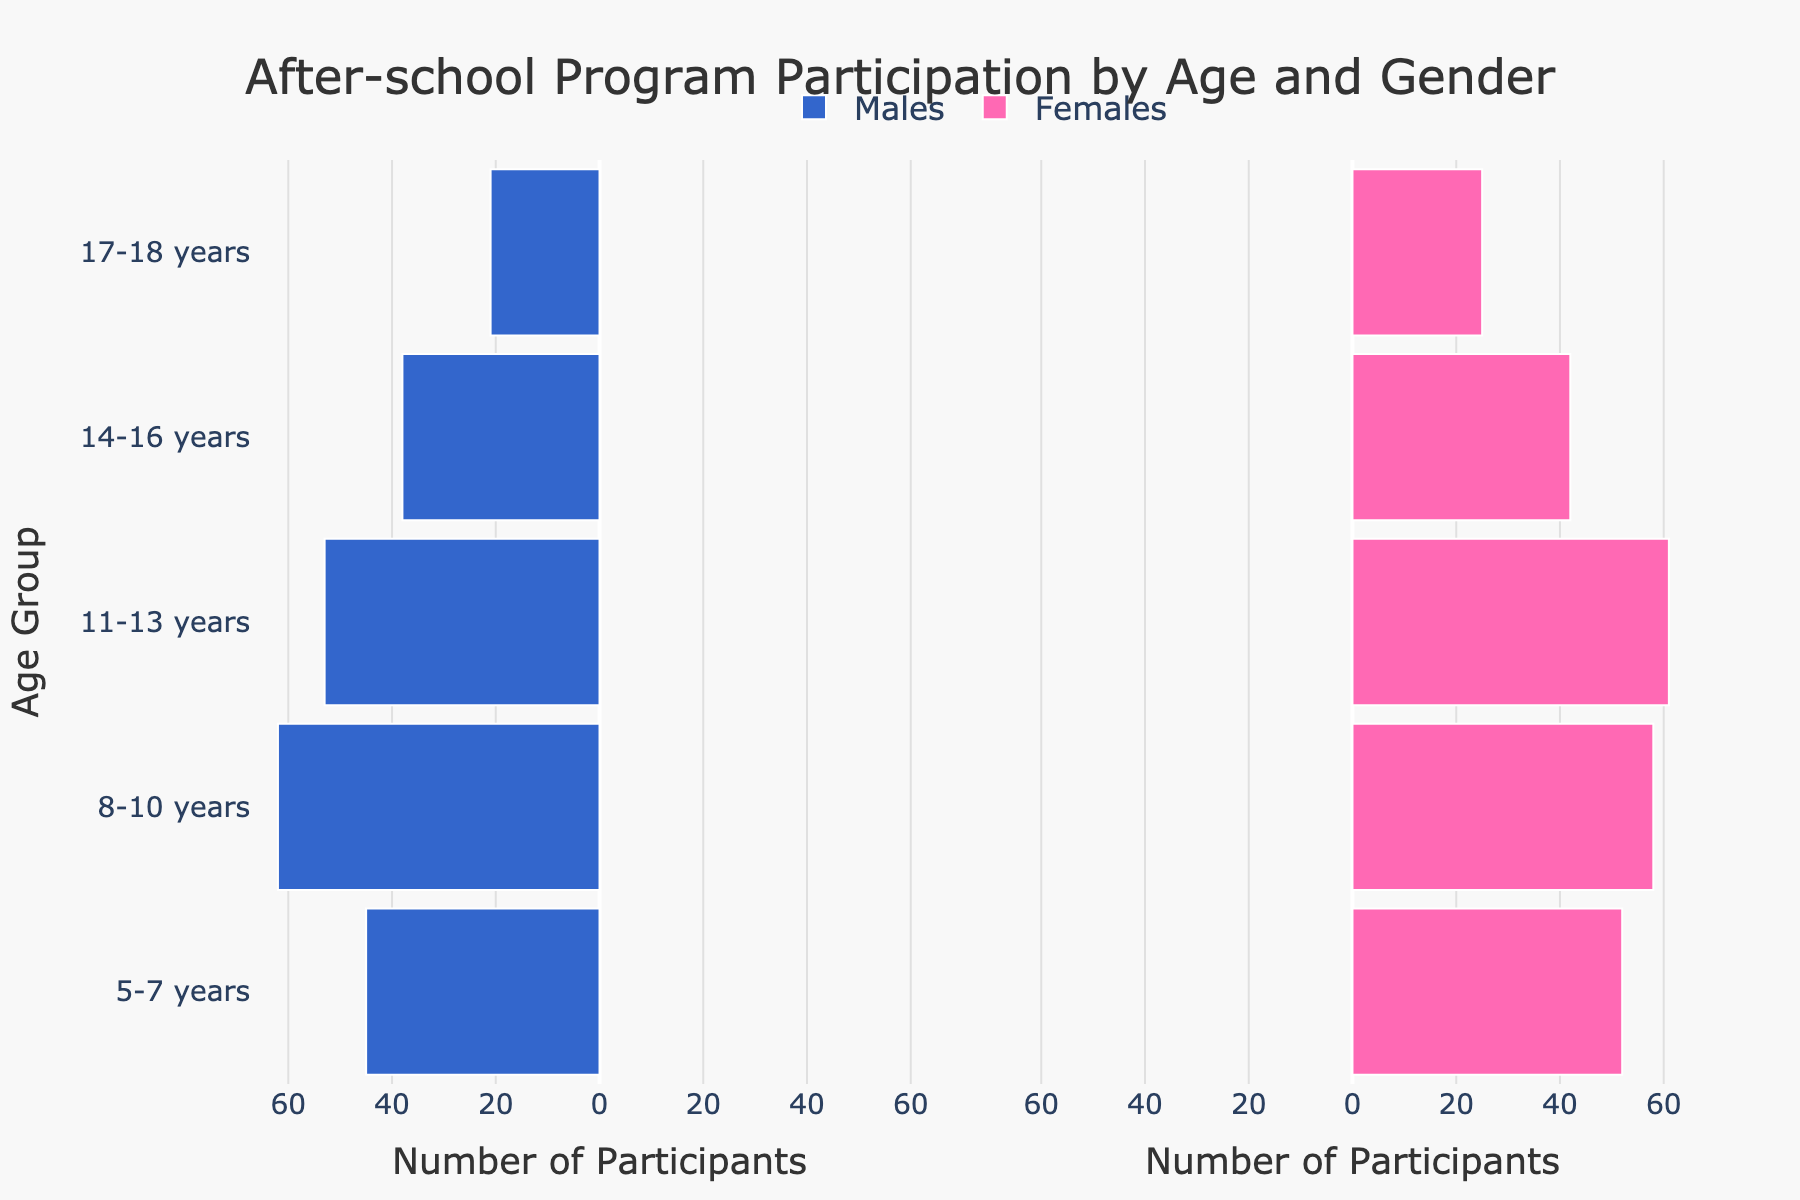What is the title of the figure? The title of the figure is located at the top and provides a succinct description of what the figure represents. The title here is "After-school Program Participation by Age and Gender."
Answer: After-school Program Participation by Age and Gender What colors are used to represent males and females in the figure? The figure uses two distinct colors to represent different genders. Males are represented by blue bars, and females are represented by pink bars.
Answer: Blue for males and pink for females Which age group has the highest number of female participants? To find this, look for the tallest pink bar (which represents females) across all the age groups. The age group "11-13 years" has the tallest pink bar, indicating the highest female participation.
Answer: 11-13 years How many male participants are there in the 8-10 years age group? Check the length of the blue bar corresponding to the "8-10 years" age group. The value there is '-62', which represents 62 male participants when considering the negative sign is just for display.
Answer: 62 What is the difference between the number of male and female participants in the 5-7 years age group? To find the difference, subtract the number of males from the number of females for the 5-7 years age group (52 - 45). This calculation shows there are 7 more females than males in this age group.
Answer: 7 Which gender has more participants in the 14-16 years age group? Compare the lengths of the blue and pink bars for the 14-16 years age group. The bar representing females is slightly taller, indicating more female participants.
Answer: Females What is the total number of participants aged 17-18 years old? Sum the number of male and female participants in the 17-18 years age group (21 males + 25 females). The total number of participants in this age group is 46.
Answer: 46 How does participation generally change as age increases from 5-7 years to 17-18 years? Examine the overall trend in the bar lengths from the youngest (5-7 years) to the oldest (17-18 years). As age increases, both the male and female participation rates generally decrease.
Answer: Decreases What's the gender ratio (males to females) in the 11-13 years age group? Calculate the ratio by dividing the number of males by the number of females in the 11-13 years age group (53 males / 61 females). Simplify the fraction to get approximately 0.87.
Answer: 0.87 Are there any age groups where the number of male participants is lower than 25? Check each age group for the blue bars representing male participants. Only the 17-18 years age group has male participants lower than 25 (21 males).
Answer: Yes, 17-18 years 